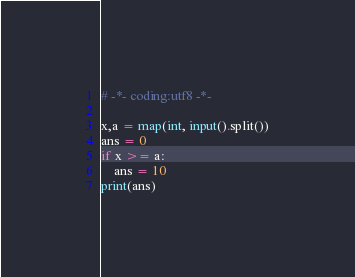Convert code to text. <code><loc_0><loc_0><loc_500><loc_500><_Python_># -*- coding:utf8 -*-

x,a = map(int, input().split())
ans = 0
if x >= a:
    ans = 10
print(ans)</code> 